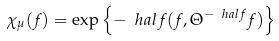Convert formula to latex. <formula><loc_0><loc_0><loc_500><loc_500>\chi _ { \mu } ( f ) = \exp \left \{ - \ h a l f ( f , \Theta ^ { - \ h a l f } f ) \right \}</formula> 